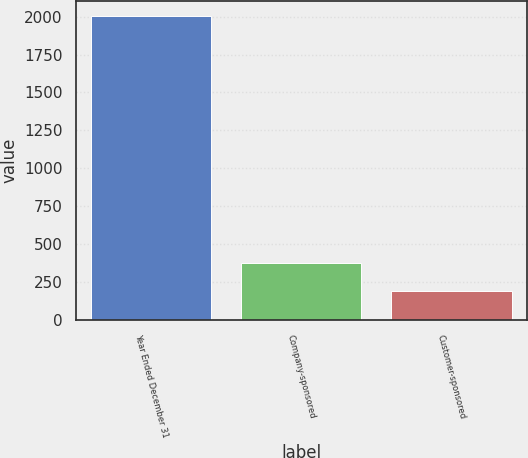<chart> <loc_0><loc_0><loc_500><loc_500><bar_chart><fcel>Year Ended December 31<fcel>Company-sponsored<fcel>Customer-sponsored<nl><fcel>2004<fcel>375<fcel>194<nl></chart> 